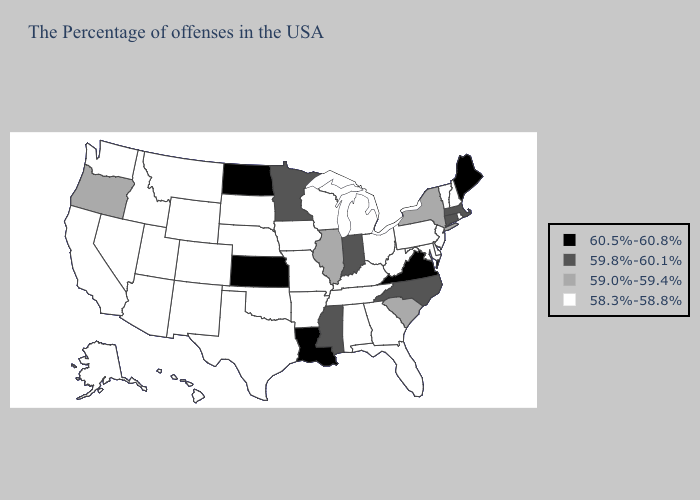What is the value of Louisiana?
Quick response, please. 60.5%-60.8%. What is the highest value in the USA?
Answer briefly. 60.5%-60.8%. Does Kansas have the highest value in the USA?
Concise answer only. Yes. Does Louisiana have the highest value in the South?
Quick response, please. Yes. What is the highest value in the South ?
Concise answer only. 60.5%-60.8%. Among the states that border Alabama , does Mississippi have the highest value?
Quick response, please. Yes. What is the value of Wisconsin?
Quick response, please. 58.3%-58.8%. Which states have the highest value in the USA?
Short answer required. Maine, Virginia, Louisiana, Kansas, North Dakota. What is the lowest value in states that border Delaware?
Keep it brief. 58.3%-58.8%. What is the value of Illinois?
Answer briefly. 59.0%-59.4%. Name the states that have a value in the range 59.8%-60.1%?
Answer briefly. Massachusetts, Connecticut, North Carolina, Indiana, Mississippi, Minnesota. What is the lowest value in the USA?
Short answer required. 58.3%-58.8%. Name the states that have a value in the range 60.5%-60.8%?
Give a very brief answer. Maine, Virginia, Louisiana, Kansas, North Dakota. Does Kansas have the same value as South Dakota?
Concise answer only. No. Name the states that have a value in the range 59.0%-59.4%?
Write a very short answer. New York, South Carolina, Illinois, Oregon. 